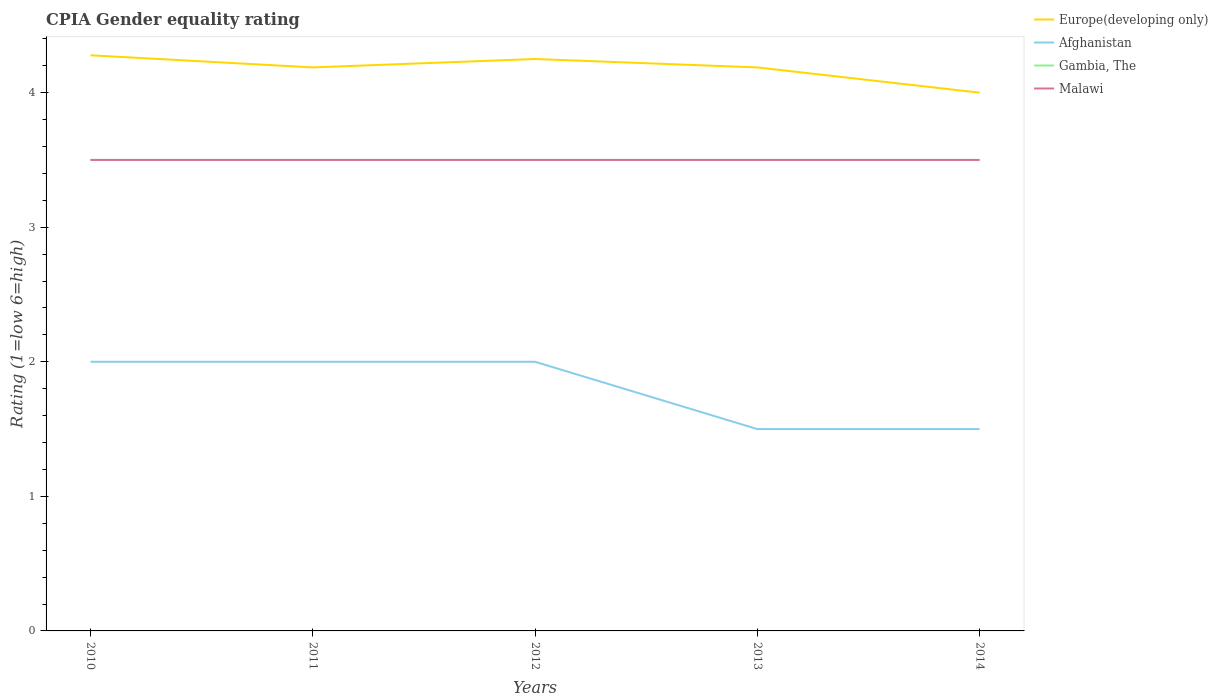What is the total CPIA rating in Afghanistan in the graph?
Provide a succinct answer. 0.5. What is the difference between the highest and the second highest CPIA rating in Afghanistan?
Your answer should be compact. 0.5. What is the difference between the highest and the lowest CPIA rating in Gambia, The?
Offer a very short reply. 0. How many lines are there?
Provide a short and direct response. 4. How many years are there in the graph?
Offer a terse response. 5. Does the graph contain grids?
Make the answer very short. No. Where does the legend appear in the graph?
Offer a terse response. Top right. What is the title of the graph?
Your response must be concise. CPIA Gender equality rating. Does "Isle of Man" appear as one of the legend labels in the graph?
Offer a terse response. No. What is the Rating (1=low 6=high) in Europe(developing only) in 2010?
Your answer should be compact. 4.28. What is the Rating (1=low 6=high) of Afghanistan in 2010?
Keep it short and to the point. 2. What is the Rating (1=low 6=high) in Gambia, The in 2010?
Offer a very short reply. 3.5. What is the Rating (1=low 6=high) of Europe(developing only) in 2011?
Keep it short and to the point. 4.19. What is the Rating (1=low 6=high) of Gambia, The in 2011?
Make the answer very short. 3.5. What is the Rating (1=low 6=high) of Europe(developing only) in 2012?
Provide a succinct answer. 4.25. What is the Rating (1=low 6=high) in Gambia, The in 2012?
Your answer should be very brief. 3.5. What is the Rating (1=low 6=high) in Europe(developing only) in 2013?
Your answer should be compact. 4.19. What is the Rating (1=low 6=high) of Afghanistan in 2013?
Make the answer very short. 1.5. What is the Rating (1=low 6=high) in Gambia, The in 2013?
Provide a succinct answer. 3.5. What is the Rating (1=low 6=high) of Malawi in 2013?
Ensure brevity in your answer.  3.5. What is the Rating (1=low 6=high) in Afghanistan in 2014?
Your response must be concise. 1.5. What is the Rating (1=low 6=high) of Gambia, The in 2014?
Your response must be concise. 3.5. Across all years, what is the maximum Rating (1=low 6=high) of Europe(developing only)?
Your answer should be very brief. 4.28. Across all years, what is the maximum Rating (1=low 6=high) in Malawi?
Provide a short and direct response. 3.5. Across all years, what is the minimum Rating (1=low 6=high) in Afghanistan?
Your response must be concise. 1.5. What is the total Rating (1=low 6=high) of Europe(developing only) in the graph?
Offer a very short reply. 20.9. What is the total Rating (1=low 6=high) of Malawi in the graph?
Give a very brief answer. 17.5. What is the difference between the Rating (1=low 6=high) of Europe(developing only) in 2010 and that in 2011?
Your answer should be very brief. 0.09. What is the difference between the Rating (1=low 6=high) in Afghanistan in 2010 and that in 2011?
Ensure brevity in your answer.  0. What is the difference between the Rating (1=low 6=high) in Malawi in 2010 and that in 2011?
Offer a terse response. 0. What is the difference between the Rating (1=low 6=high) of Europe(developing only) in 2010 and that in 2012?
Provide a short and direct response. 0.03. What is the difference between the Rating (1=low 6=high) of Afghanistan in 2010 and that in 2012?
Your answer should be compact. 0. What is the difference between the Rating (1=low 6=high) of Gambia, The in 2010 and that in 2012?
Provide a short and direct response. 0. What is the difference between the Rating (1=low 6=high) in Malawi in 2010 and that in 2012?
Provide a succinct answer. 0. What is the difference between the Rating (1=low 6=high) of Europe(developing only) in 2010 and that in 2013?
Provide a succinct answer. 0.09. What is the difference between the Rating (1=low 6=high) of Gambia, The in 2010 and that in 2013?
Ensure brevity in your answer.  0. What is the difference between the Rating (1=low 6=high) of Malawi in 2010 and that in 2013?
Keep it short and to the point. 0. What is the difference between the Rating (1=low 6=high) in Europe(developing only) in 2010 and that in 2014?
Keep it short and to the point. 0.28. What is the difference between the Rating (1=low 6=high) of Afghanistan in 2010 and that in 2014?
Give a very brief answer. 0.5. What is the difference between the Rating (1=low 6=high) in Europe(developing only) in 2011 and that in 2012?
Your answer should be compact. -0.06. What is the difference between the Rating (1=low 6=high) of Afghanistan in 2011 and that in 2012?
Offer a terse response. 0. What is the difference between the Rating (1=low 6=high) in Gambia, The in 2011 and that in 2012?
Keep it short and to the point. 0. What is the difference between the Rating (1=low 6=high) of Malawi in 2011 and that in 2013?
Offer a very short reply. 0. What is the difference between the Rating (1=low 6=high) of Europe(developing only) in 2011 and that in 2014?
Your answer should be very brief. 0.19. What is the difference between the Rating (1=low 6=high) of Afghanistan in 2011 and that in 2014?
Make the answer very short. 0.5. What is the difference between the Rating (1=low 6=high) of Europe(developing only) in 2012 and that in 2013?
Provide a succinct answer. 0.06. What is the difference between the Rating (1=low 6=high) of Afghanistan in 2012 and that in 2013?
Provide a succinct answer. 0.5. What is the difference between the Rating (1=low 6=high) of Afghanistan in 2012 and that in 2014?
Ensure brevity in your answer.  0.5. What is the difference between the Rating (1=low 6=high) of Malawi in 2012 and that in 2014?
Your answer should be compact. 0. What is the difference between the Rating (1=low 6=high) in Europe(developing only) in 2013 and that in 2014?
Provide a succinct answer. 0.19. What is the difference between the Rating (1=low 6=high) in Gambia, The in 2013 and that in 2014?
Give a very brief answer. 0. What is the difference between the Rating (1=low 6=high) of Europe(developing only) in 2010 and the Rating (1=low 6=high) of Afghanistan in 2011?
Ensure brevity in your answer.  2.28. What is the difference between the Rating (1=low 6=high) of Afghanistan in 2010 and the Rating (1=low 6=high) of Gambia, The in 2011?
Offer a terse response. -1.5. What is the difference between the Rating (1=low 6=high) of Europe(developing only) in 2010 and the Rating (1=low 6=high) of Afghanistan in 2012?
Provide a succinct answer. 2.28. What is the difference between the Rating (1=low 6=high) in Europe(developing only) in 2010 and the Rating (1=low 6=high) in Malawi in 2012?
Your answer should be very brief. 0.78. What is the difference between the Rating (1=low 6=high) of Afghanistan in 2010 and the Rating (1=low 6=high) of Malawi in 2012?
Offer a very short reply. -1.5. What is the difference between the Rating (1=low 6=high) in Gambia, The in 2010 and the Rating (1=low 6=high) in Malawi in 2012?
Offer a very short reply. 0. What is the difference between the Rating (1=low 6=high) of Europe(developing only) in 2010 and the Rating (1=low 6=high) of Afghanistan in 2013?
Your answer should be very brief. 2.78. What is the difference between the Rating (1=low 6=high) in Europe(developing only) in 2010 and the Rating (1=low 6=high) in Malawi in 2013?
Keep it short and to the point. 0.78. What is the difference between the Rating (1=low 6=high) in Afghanistan in 2010 and the Rating (1=low 6=high) in Gambia, The in 2013?
Offer a terse response. -1.5. What is the difference between the Rating (1=low 6=high) of Afghanistan in 2010 and the Rating (1=low 6=high) of Malawi in 2013?
Provide a succinct answer. -1.5. What is the difference between the Rating (1=low 6=high) in Gambia, The in 2010 and the Rating (1=low 6=high) in Malawi in 2013?
Ensure brevity in your answer.  0. What is the difference between the Rating (1=low 6=high) in Europe(developing only) in 2010 and the Rating (1=low 6=high) in Afghanistan in 2014?
Provide a short and direct response. 2.78. What is the difference between the Rating (1=low 6=high) in Afghanistan in 2010 and the Rating (1=low 6=high) in Malawi in 2014?
Offer a terse response. -1.5. What is the difference between the Rating (1=low 6=high) of Europe(developing only) in 2011 and the Rating (1=low 6=high) of Afghanistan in 2012?
Give a very brief answer. 2.19. What is the difference between the Rating (1=low 6=high) of Europe(developing only) in 2011 and the Rating (1=low 6=high) of Gambia, The in 2012?
Keep it short and to the point. 0.69. What is the difference between the Rating (1=low 6=high) in Europe(developing only) in 2011 and the Rating (1=low 6=high) in Malawi in 2012?
Offer a terse response. 0.69. What is the difference between the Rating (1=low 6=high) in Europe(developing only) in 2011 and the Rating (1=low 6=high) in Afghanistan in 2013?
Your response must be concise. 2.69. What is the difference between the Rating (1=low 6=high) in Europe(developing only) in 2011 and the Rating (1=low 6=high) in Gambia, The in 2013?
Your answer should be compact. 0.69. What is the difference between the Rating (1=low 6=high) of Europe(developing only) in 2011 and the Rating (1=low 6=high) of Malawi in 2013?
Offer a very short reply. 0.69. What is the difference between the Rating (1=low 6=high) of Afghanistan in 2011 and the Rating (1=low 6=high) of Gambia, The in 2013?
Your response must be concise. -1.5. What is the difference between the Rating (1=low 6=high) in Europe(developing only) in 2011 and the Rating (1=low 6=high) in Afghanistan in 2014?
Offer a terse response. 2.69. What is the difference between the Rating (1=low 6=high) of Europe(developing only) in 2011 and the Rating (1=low 6=high) of Gambia, The in 2014?
Offer a very short reply. 0.69. What is the difference between the Rating (1=low 6=high) of Europe(developing only) in 2011 and the Rating (1=low 6=high) of Malawi in 2014?
Make the answer very short. 0.69. What is the difference between the Rating (1=low 6=high) of Afghanistan in 2011 and the Rating (1=low 6=high) of Gambia, The in 2014?
Offer a terse response. -1.5. What is the difference between the Rating (1=low 6=high) in Gambia, The in 2011 and the Rating (1=low 6=high) in Malawi in 2014?
Give a very brief answer. 0. What is the difference between the Rating (1=low 6=high) of Europe(developing only) in 2012 and the Rating (1=low 6=high) of Afghanistan in 2013?
Your answer should be very brief. 2.75. What is the difference between the Rating (1=low 6=high) of Europe(developing only) in 2012 and the Rating (1=low 6=high) of Gambia, The in 2013?
Give a very brief answer. 0.75. What is the difference between the Rating (1=low 6=high) in Europe(developing only) in 2012 and the Rating (1=low 6=high) in Malawi in 2013?
Give a very brief answer. 0.75. What is the difference between the Rating (1=low 6=high) of Afghanistan in 2012 and the Rating (1=low 6=high) of Gambia, The in 2013?
Provide a short and direct response. -1.5. What is the difference between the Rating (1=low 6=high) in Afghanistan in 2012 and the Rating (1=low 6=high) in Malawi in 2013?
Offer a very short reply. -1.5. What is the difference between the Rating (1=low 6=high) in Gambia, The in 2012 and the Rating (1=low 6=high) in Malawi in 2013?
Your answer should be compact. 0. What is the difference between the Rating (1=low 6=high) of Europe(developing only) in 2012 and the Rating (1=low 6=high) of Afghanistan in 2014?
Make the answer very short. 2.75. What is the difference between the Rating (1=low 6=high) of Europe(developing only) in 2012 and the Rating (1=low 6=high) of Gambia, The in 2014?
Offer a very short reply. 0.75. What is the difference between the Rating (1=low 6=high) in Europe(developing only) in 2012 and the Rating (1=low 6=high) in Malawi in 2014?
Your answer should be compact. 0.75. What is the difference between the Rating (1=low 6=high) in Afghanistan in 2012 and the Rating (1=low 6=high) in Malawi in 2014?
Keep it short and to the point. -1.5. What is the difference between the Rating (1=low 6=high) in Gambia, The in 2012 and the Rating (1=low 6=high) in Malawi in 2014?
Offer a very short reply. 0. What is the difference between the Rating (1=low 6=high) of Europe(developing only) in 2013 and the Rating (1=low 6=high) of Afghanistan in 2014?
Give a very brief answer. 2.69. What is the difference between the Rating (1=low 6=high) in Europe(developing only) in 2013 and the Rating (1=low 6=high) in Gambia, The in 2014?
Offer a terse response. 0.69. What is the difference between the Rating (1=low 6=high) of Europe(developing only) in 2013 and the Rating (1=low 6=high) of Malawi in 2014?
Give a very brief answer. 0.69. What is the average Rating (1=low 6=high) in Europe(developing only) per year?
Give a very brief answer. 4.18. What is the average Rating (1=low 6=high) of Gambia, The per year?
Your answer should be very brief. 3.5. What is the average Rating (1=low 6=high) of Malawi per year?
Keep it short and to the point. 3.5. In the year 2010, what is the difference between the Rating (1=low 6=high) in Europe(developing only) and Rating (1=low 6=high) in Afghanistan?
Ensure brevity in your answer.  2.28. In the year 2010, what is the difference between the Rating (1=low 6=high) in Europe(developing only) and Rating (1=low 6=high) in Malawi?
Your answer should be compact. 0.78. In the year 2010, what is the difference between the Rating (1=low 6=high) in Afghanistan and Rating (1=low 6=high) in Malawi?
Your answer should be very brief. -1.5. In the year 2010, what is the difference between the Rating (1=low 6=high) in Gambia, The and Rating (1=low 6=high) in Malawi?
Make the answer very short. 0. In the year 2011, what is the difference between the Rating (1=low 6=high) in Europe(developing only) and Rating (1=low 6=high) in Afghanistan?
Give a very brief answer. 2.19. In the year 2011, what is the difference between the Rating (1=low 6=high) of Europe(developing only) and Rating (1=low 6=high) of Gambia, The?
Give a very brief answer. 0.69. In the year 2011, what is the difference between the Rating (1=low 6=high) in Europe(developing only) and Rating (1=low 6=high) in Malawi?
Your answer should be compact. 0.69. In the year 2011, what is the difference between the Rating (1=low 6=high) in Afghanistan and Rating (1=low 6=high) in Gambia, The?
Your answer should be very brief. -1.5. In the year 2011, what is the difference between the Rating (1=low 6=high) of Afghanistan and Rating (1=low 6=high) of Malawi?
Provide a short and direct response. -1.5. In the year 2011, what is the difference between the Rating (1=low 6=high) in Gambia, The and Rating (1=low 6=high) in Malawi?
Your response must be concise. 0. In the year 2012, what is the difference between the Rating (1=low 6=high) in Europe(developing only) and Rating (1=low 6=high) in Afghanistan?
Offer a very short reply. 2.25. In the year 2012, what is the difference between the Rating (1=low 6=high) in Europe(developing only) and Rating (1=low 6=high) in Gambia, The?
Make the answer very short. 0.75. In the year 2012, what is the difference between the Rating (1=low 6=high) in Gambia, The and Rating (1=low 6=high) in Malawi?
Make the answer very short. 0. In the year 2013, what is the difference between the Rating (1=low 6=high) of Europe(developing only) and Rating (1=low 6=high) of Afghanistan?
Keep it short and to the point. 2.69. In the year 2013, what is the difference between the Rating (1=low 6=high) in Europe(developing only) and Rating (1=low 6=high) in Gambia, The?
Ensure brevity in your answer.  0.69. In the year 2013, what is the difference between the Rating (1=low 6=high) of Europe(developing only) and Rating (1=low 6=high) of Malawi?
Give a very brief answer. 0.69. In the year 2013, what is the difference between the Rating (1=low 6=high) of Afghanistan and Rating (1=low 6=high) of Gambia, The?
Your answer should be compact. -2. In the year 2013, what is the difference between the Rating (1=low 6=high) of Afghanistan and Rating (1=low 6=high) of Malawi?
Make the answer very short. -2. In the year 2014, what is the difference between the Rating (1=low 6=high) in Europe(developing only) and Rating (1=low 6=high) in Afghanistan?
Keep it short and to the point. 2.5. In the year 2014, what is the difference between the Rating (1=low 6=high) in Europe(developing only) and Rating (1=low 6=high) in Gambia, The?
Offer a terse response. 0.5. In the year 2014, what is the difference between the Rating (1=low 6=high) in Afghanistan and Rating (1=low 6=high) in Malawi?
Offer a very short reply. -2. In the year 2014, what is the difference between the Rating (1=low 6=high) of Gambia, The and Rating (1=low 6=high) of Malawi?
Your response must be concise. 0. What is the ratio of the Rating (1=low 6=high) in Europe(developing only) in 2010 to that in 2011?
Offer a terse response. 1.02. What is the ratio of the Rating (1=low 6=high) of Afghanistan in 2010 to that in 2011?
Offer a very short reply. 1. What is the ratio of the Rating (1=low 6=high) in Afghanistan in 2010 to that in 2012?
Make the answer very short. 1. What is the ratio of the Rating (1=low 6=high) in Malawi in 2010 to that in 2012?
Keep it short and to the point. 1. What is the ratio of the Rating (1=low 6=high) in Europe(developing only) in 2010 to that in 2013?
Keep it short and to the point. 1.02. What is the ratio of the Rating (1=low 6=high) in Afghanistan in 2010 to that in 2013?
Your answer should be compact. 1.33. What is the ratio of the Rating (1=low 6=high) in Gambia, The in 2010 to that in 2013?
Provide a succinct answer. 1. What is the ratio of the Rating (1=low 6=high) in Europe(developing only) in 2010 to that in 2014?
Make the answer very short. 1.07. What is the ratio of the Rating (1=low 6=high) of Gambia, The in 2010 to that in 2014?
Keep it short and to the point. 1. What is the ratio of the Rating (1=low 6=high) in Malawi in 2010 to that in 2014?
Your response must be concise. 1. What is the ratio of the Rating (1=low 6=high) in Europe(developing only) in 2011 to that in 2012?
Your answer should be very brief. 0.99. What is the ratio of the Rating (1=low 6=high) of Europe(developing only) in 2011 to that in 2013?
Provide a succinct answer. 1. What is the ratio of the Rating (1=low 6=high) of Afghanistan in 2011 to that in 2013?
Provide a short and direct response. 1.33. What is the ratio of the Rating (1=low 6=high) of Malawi in 2011 to that in 2013?
Your answer should be very brief. 1. What is the ratio of the Rating (1=low 6=high) in Europe(developing only) in 2011 to that in 2014?
Offer a very short reply. 1.05. What is the ratio of the Rating (1=low 6=high) in Afghanistan in 2011 to that in 2014?
Give a very brief answer. 1.33. What is the ratio of the Rating (1=low 6=high) of Malawi in 2011 to that in 2014?
Keep it short and to the point. 1. What is the ratio of the Rating (1=low 6=high) in Europe(developing only) in 2012 to that in 2013?
Ensure brevity in your answer.  1.01. What is the ratio of the Rating (1=low 6=high) in Afghanistan in 2012 to that in 2013?
Your answer should be very brief. 1.33. What is the ratio of the Rating (1=low 6=high) in Europe(developing only) in 2012 to that in 2014?
Your response must be concise. 1.06. What is the ratio of the Rating (1=low 6=high) in Malawi in 2012 to that in 2014?
Provide a succinct answer. 1. What is the ratio of the Rating (1=low 6=high) in Europe(developing only) in 2013 to that in 2014?
Ensure brevity in your answer.  1.05. What is the ratio of the Rating (1=low 6=high) of Gambia, The in 2013 to that in 2014?
Give a very brief answer. 1. What is the difference between the highest and the second highest Rating (1=low 6=high) in Europe(developing only)?
Make the answer very short. 0.03. What is the difference between the highest and the second highest Rating (1=low 6=high) of Afghanistan?
Offer a very short reply. 0. What is the difference between the highest and the second highest Rating (1=low 6=high) of Malawi?
Make the answer very short. 0. What is the difference between the highest and the lowest Rating (1=low 6=high) in Europe(developing only)?
Offer a terse response. 0.28. What is the difference between the highest and the lowest Rating (1=low 6=high) of Afghanistan?
Give a very brief answer. 0.5. 